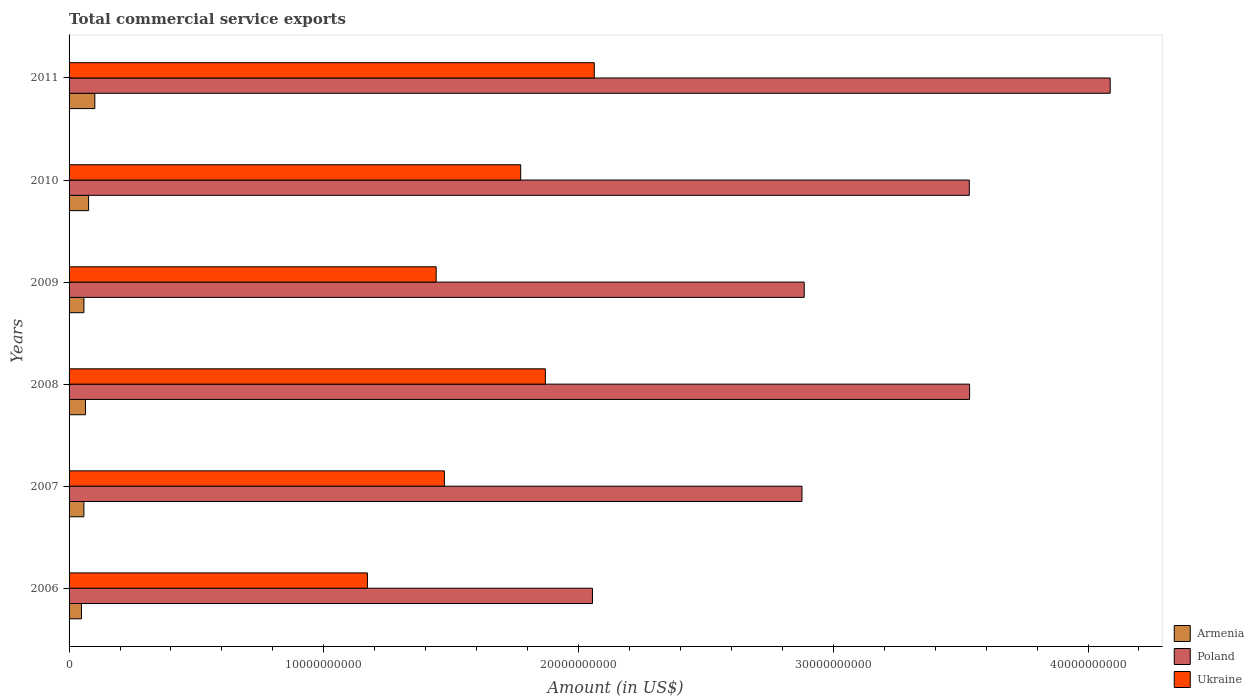How many bars are there on the 2nd tick from the top?
Give a very brief answer. 3. What is the label of the 3rd group of bars from the top?
Ensure brevity in your answer.  2009. In how many cases, is the number of bars for a given year not equal to the number of legend labels?
Provide a short and direct response. 0. What is the total commercial service exports in Ukraine in 2010?
Provide a succinct answer. 1.77e+1. Across all years, what is the maximum total commercial service exports in Poland?
Your response must be concise. 4.09e+1. Across all years, what is the minimum total commercial service exports in Poland?
Offer a terse response. 2.05e+1. In which year was the total commercial service exports in Ukraine maximum?
Offer a very short reply. 2011. What is the total total commercial service exports in Poland in the graph?
Your answer should be compact. 1.90e+11. What is the difference between the total commercial service exports in Armenia in 2008 and that in 2010?
Offer a very short reply. -1.21e+08. What is the difference between the total commercial service exports in Ukraine in 2010 and the total commercial service exports in Armenia in 2008?
Give a very brief answer. 1.71e+1. What is the average total commercial service exports in Armenia per year?
Keep it short and to the point. 6.79e+08. In the year 2009, what is the difference between the total commercial service exports in Poland and total commercial service exports in Armenia?
Your response must be concise. 2.83e+1. In how many years, is the total commercial service exports in Armenia greater than 38000000000 US$?
Make the answer very short. 0. What is the ratio of the total commercial service exports in Ukraine in 2010 to that in 2011?
Ensure brevity in your answer.  0.86. Is the total commercial service exports in Armenia in 2006 less than that in 2008?
Provide a short and direct response. Yes. Is the difference between the total commercial service exports in Poland in 2007 and 2008 greater than the difference between the total commercial service exports in Armenia in 2007 and 2008?
Provide a short and direct response. No. What is the difference between the highest and the second highest total commercial service exports in Ukraine?
Provide a succinct answer. 1.92e+09. What is the difference between the highest and the lowest total commercial service exports in Ukraine?
Your answer should be very brief. 8.90e+09. In how many years, is the total commercial service exports in Ukraine greater than the average total commercial service exports in Ukraine taken over all years?
Keep it short and to the point. 3. What does the 3rd bar from the bottom in 2011 represents?
Offer a very short reply. Ukraine. How many bars are there?
Provide a succinct answer. 18. Are all the bars in the graph horizontal?
Offer a very short reply. Yes. How many years are there in the graph?
Offer a terse response. 6. Are the values on the major ticks of X-axis written in scientific E-notation?
Your answer should be very brief. No. Does the graph contain grids?
Provide a short and direct response. No. How many legend labels are there?
Your answer should be very brief. 3. How are the legend labels stacked?
Your answer should be very brief. Vertical. What is the title of the graph?
Make the answer very short. Total commercial service exports. Does "San Marino" appear as one of the legend labels in the graph?
Provide a succinct answer. No. What is the label or title of the X-axis?
Provide a short and direct response. Amount (in US$). What is the Amount (in US$) of Armenia in 2006?
Make the answer very short. 4.87e+08. What is the Amount (in US$) in Poland in 2006?
Give a very brief answer. 2.05e+1. What is the Amount (in US$) of Ukraine in 2006?
Your response must be concise. 1.17e+1. What is the Amount (in US$) of Armenia in 2007?
Make the answer very short. 5.82e+08. What is the Amount (in US$) of Poland in 2007?
Offer a terse response. 2.88e+1. What is the Amount (in US$) of Ukraine in 2007?
Provide a short and direct response. 1.47e+1. What is the Amount (in US$) in Armenia in 2008?
Give a very brief answer. 6.45e+08. What is the Amount (in US$) in Poland in 2008?
Keep it short and to the point. 3.54e+1. What is the Amount (in US$) in Ukraine in 2008?
Offer a very short reply. 1.87e+1. What is the Amount (in US$) of Armenia in 2009?
Offer a very short reply. 5.83e+08. What is the Amount (in US$) of Poland in 2009?
Keep it short and to the point. 2.89e+1. What is the Amount (in US$) in Ukraine in 2009?
Provide a succinct answer. 1.44e+1. What is the Amount (in US$) in Armenia in 2010?
Offer a terse response. 7.66e+08. What is the Amount (in US$) in Poland in 2010?
Provide a succinct answer. 3.53e+1. What is the Amount (in US$) in Ukraine in 2010?
Your answer should be very brief. 1.77e+1. What is the Amount (in US$) in Armenia in 2011?
Your answer should be compact. 1.01e+09. What is the Amount (in US$) of Poland in 2011?
Provide a succinct answer. 4.09e+1. What is the Amount (in US$) of Ukraine in 2011?
Give a very brief answer. 2.06e+1. Across all years, what is the maximum Amount (in US$) of Armenia?
Ensure brevity in your answer.  1.01e+09. Across all years, what is the maximum Amount (in US$) in Poland?
Provide a succinct answer. 4.09e+1. Across all years, what is the maximum Amount (in US$) in Ukraine?
Provide a short and direct response. 2.06e+1. Across all years, what is the minimum Amount (in US$) of Armenia?
Offer a terse response. 4.87e+08. Across all years, what is the minimum Amount (in US$) in Poland?
Ensure brevity in your answer.  2.05e+1. Across all years, what is the minimum Amount (in US$) of Ukraine?
Give a very brief answer. 1.17e+1. What is the total Amount (in US$) of Armenia in the graph?
Your response must be concise. 4.08e+09. What is the total Amount (in US$) in Poland in the graph?
Ensure brevity in your answer.  1.90e+11. What is the total Amount (in US$) of Ukraine in the graph?
Ensure brevity in your answer.  9.79e+1. What is the difference between the Amount (in US$) in Armenia in 2006 and that in 2007?
Provide a succinct answer. -9.43e+07. What is the difference between the Amount (in US$) of Poland in 2006 and that in 2007?
Ensure brevity in your answer.  -8.22e+09. What is the difference between the Amount (in US$) in Ukraine in 2006 and that in 2007?
Give a very brief answer. -3.02e+09. What is the difference between the Amount (in US$) in Armenia in 2006 and that in 2008?
Your answer should be very brief. -1.58e+08. What is the difference between the Amount (in US$) in Poland in 2006 and that in 2008?
Your answer should be compact. -1.48e+1. What is the difference between the Amount (in US$) of Ukraine in 2006 and that in 2008?
Your answer should be very brief. -6.99e+09. What is the difference between the Amount (in US$) in Armenia in 2006 and that in 2009?
Provide a short and direct response. -9.58e+07. What is the difference between the Amount (in US$) of Poland in 2006 and that in 2009?
Your answer should be very brief. -8.31e+09. What is the difference between the Amount (in US$) in Ukraine in 2006 and that in 2009?
Keep it short and to the point. -2.70e+09. What is the difference between the Amount (in US$) of Armenia in 2006 and that in 2010?
Ensure brevity in your answer.  -2.79e+08. What is the difference between the Amount (in US$) of Poland in 2006 and that in 2010?
Your response must be concise. -1.48e+1. What is the difference between the Amount (in US$) of Ukraine in 2006 and that in 2010?
Keep it short and to the point. -6.02e+09. What is the difference between the Amount (in US$) of Armenia in 2006 and that in 2011?
Ensure brevity in your answer.  -5.24e+08. What is the difference between the Amount (in US$) in Poland in 2006 and that in 2011?
Offer a terse response. -2.03e+1. What is the difference between the Amount (in US$) in Ukraine in 2006 and that in 2011?
Provide a short and direct response. -8.90e+09. What is the difference between the Amount (in US$) in Armenia in 2007 and that in 2008?
Provide a succinct answer. -6.33e+07. What is the difference between the Amount (in US$) in Poland in 2007 and that in 2008?
Give a very brief answer. -6.58e+09. What is the difference between the Amount (in US$) of Ukraine in 2007 and that in 2008?
Make the answer very short. -3.96e+09. What is the difference between the Amount (in US$) in Armenia in 2007 and that in 2009?
Ensure brevity in your answer.  -1.47e+06. What is the difference between the Amount (in US$) of Poland in 2007 and that in 2009?
Your answer should be compact. -8.80e+07. What is the difference between the Amount (in US$) of Ukraine in 2007 and that in 2009?
Your answer should be compact. 3.23e+08. What is the difference between the Amount (in US$) of Armenia in 2007 and that in 2010?
Your answer should be very brief. -1.85e+08. What is the difference between the Amount (in US$) in Poland in 2007 and that in 2010?
Keep it short and to the point. -6.57e+09. What is the difference between the Amount (in US$) of Ukraine in 2007 and that in 2010?
Make the answer very short. -3.00e+09. What is the difference between the Amount (in US$) of Armenia in 2007 and that in 2011?
Your response must be concise. -4.30e+08. What is the difference between the Amount (in US$) in Poland in 2007 and that in 2011?
Provide a succinct answer. -1.21e+1. What is the difference between the Amount (in US$) in Ukraine in 2007 and that in 2011?
Your response must be concise. -5.88e+09. What is the difference between the Amount (in US$) of Armenia in 2008 and that in 2009?
Provide a succinct answer. 6.18e+07. What is the difference between the Amount (in US$) of Poland in 2008 and that in 2009?
Provide a succinct answer. 6.49e+09. What is the difference between the Amount (in US$) of Ukraine in 2008 and that in 2009?
Ensure brevity in your answer.  4.29e+09. What is the difference between the Amount (in US$) in Armenia in 2008 and that in 2010?
Your answer should be compact. -1.21e+08. What is the difference between the Amount (in US$) of Poland in 2008 and that in 2010?
Provide a short and direct response. 1.10e+07. What is the difference between the Amount (in US$) of Ukraine in 2008 and that in 2010?
Ensure brevity in your answer.  9.70e+08. What is the difference between the Amount (in US$) of Armenia in 2008 and that in 2011?
Provide a short and direct response. -3.66e+08. What is the difference between the Amount (in US$) of Poland in 2008 and that in 2011?
Your answer should be compact. -5.52e+09. What is the difference between the Amount (in US$) of Ukraine in 2008 and that in 2011?
Ensure brevity in your answer.  -1.92e+09. What is the difference between the Amount (in US$) in Armenia in 2009 and that in 2010?
Provide a succinct answer. -1.83e+08. What is the difference between the Amount (in US$) of Poland in 2009 and that in 2010?
Offer a terse response. -6.48e+09. What is the difference between the Amount (in US$) in Ukraine in 2009 and that in 2010?
Your response must be concise. -3.32e+09. What is the difference between the Amount (in US$) of Armenia in 2009 and that in 2011?
Your answer should be very brief. -4.28e+08. What is the difference between the Amount (in US$) of Poland in 2009 and that in 2011?
Your answer should be very brief. -1.20e+1. What is the difference between the Amount (in US$) in Ukraine in 2009 and that in 2011?
Provide a short and direct response. -6.21e+09. What is the difference between the Amount (in US$) in Armenia in 2010 and that in 2011?
Ensure brevity in your answer.  -2.45e+08. What is the difference between the Amount (in US$) of Poland in 2010 and that in 2011?
Keep it short and to the point. -5.53e+09. What is the difference between the Amount (in US$) in Ukraine in 2010 and that in 2011?
Give a very brief answer. -2.89e+09. What is the difference between the Amount (in US$) in Armenia in 2006 and the Amount (in US$) in Poland in 2007?
Offer a terse response. -2.83e+1. What is the difference between the Amount (in US$) of Armenia in 2006 and the Amount (in US$) of Ukraine in 2007?
Give a very brief answer. -1.42e+1. What is the difference between the Amount (in US$) of Poland in 2006 and the Amount (in US$) of Ukraine in 2007?
Provide a short and direct response. 5.81e+09. What is the difference between the Amount (in US$) in Armenia in 2006 and the Amount (in US$) in Poland in 2008?
Provide a succinct answer. -3.49e+1. What is the difference between the Amount (in US$) of Armenia in 2006 and the Amount (in US$) of Ukraine in 2008?
Make the answer very short. -1.82e+1. What is the difference between the Amount (in US$) in Poland in 2006 and the Amount (in US$) in Ukraine in 2008?
Provide a short and direct response. 1.85e+09. What is the difference between the Amount (in US$) of Armenia in 2006 and the Amount (in US$) of Poland in 2009?
Your response must be concise. -2.84e+1. What is the difference between the Amount (in US$) in Armenia in 2006 and the Amount (in US$) in Ukraine in 2009?
Keep it short and to the point. -1.39e+1. What is the difference between the Amount (in US$) of Poland in 2006 and the Amount (in US$) of Ukraine in 2009?
Provide a short and direct response. 6.14e+09. What is the difference between the Amount (in US$) in Armenia in 2006 and the Amount (in US$) in Poland in 2010?
Your answer should be very brief. -3.49e+1. What is the difference between the Amount (in US$) of Armenia in 2006 and the Amount (in US$) of Ukraine in 2010?
Your response must be concise. -1.72e+1. What is the difference between the Amount (in US$) of Poland in 2006 and the Amount (in US$) of Ukraine in 2010?
Give a very brief answer. 2.82e+09. What is the difference between the Amount (in US$) of Armenia in 2006 and the Amount (in US$) of Poland in 2011?
Your answer should be compact. -4.04e+1. What is the difference between the Amount (in US$) of Armenia in 2006 and the Amount (in US$) of Ukraine in 2011?
Ensure brevity in your answer.  -2.01e+1. What is the difference between the Amount (in US$) of Poland in 2006 and the Amount (in US$) of Ukraine in 2011?
Your response must be concise. -7.10e+07. What is the difference between the Amount (in US$) in Armenia in 2007 and the Amount (in US$) in Poland in 2008?
Ensure brevity in your answer.  -3.48e+1. What is the difference between the Amount (in US$) in Armenia in 2007 and the Amount (in US$) in Ukraine in 2008?
Ensure brevity in your answer.  -1.81e+1. What is the difference between the Amount (in US$) in Poland in 2007 and the Amount (in US$) in Ukraine in 2008?
Provide a succinct answer. 1.01e+1. What is the difference between the Amount (in US$) of Armenia in 2007 and the Amount (in US$) of Poland in 2009?
Provide a succinct answer. -2.83e+1. What is the difference between the Amount (in US$) of Armenia in 2007 and the Amount (in US$) of Ukraine in 2009?
Ensure brevity in your answer.  -1.38e+1. What is the difference between the Amount (in US$) of Poland in 2007 and the Amount (in US$) of Ukraine in 2009?
Your response must be concise. 1.44e+1. What is the difference between the Amount (in US$) in Armenia in 2007 and the Amount (in US$) in Poland in 2010?
Provide a succinct answer. -3.48e+1. What is the difference between the Amount (in US$) of Armenia in 2007 and the Amount (in US$) of Ukraine in 2010?
Your answer should be compact. -1.71e+1. What is the difference between the Amount (in US$) in Poland in 2007 and the Amount (in US$) in Ukraine in 2010?
Your answer should be compact. 1.10e+1. What is the difference between the Amount (in US$) of Armenia in 2007 and the Amount (in US$) of Poland in 2011?
Your response must be concise. -4.03e+1. What is the difference between the Amount (in US$) of Armenia in 2007 and the Amount (in US$) of Ukraine in 2011?
Provide a short and direct response. -2.00e+1. What is the difference between the Amount (in US$) of Poland in 2007 and the Amount (in US$) of Ukraine in 2011?
Ensure brevity in your answer.  8.15e+09. What is the difference between the Amount (in US$) of Armenia in 2008 and the Amount (in US$) of Poland in 2009?
Provide a succinct answer. -2.82e+1. What is the difference between the Amount (in US$) in Armenia in 2008 and the Amount (in US$) in Ukraine in 2009?
Keep it short and to the point. -1.38e+1. What is the difference between the Amount (in US$) in Poland in 2008 and the Amount (in US$) in Ukraine in 2009?
Make the answer very short. 2.09e+1. What is the difference between the Amount (in US$) in Armenia in 2008 and the Amount (in US$) in Poland in 2010?
Provide a succinct answer. -3.47e+1. What is the difference between the Amount (in US$) in Armenia in 2008 and the Amount (in US$) in Ukraine in 2010?
Your answer should be very brief. -1.71e+1. What is the difference between the Amount (in US$) of Poland in 2008 and the Amount (in US$) of Ukraine in 2010?
Your response must be concise. 1.76e+1. What is the difference between the Amount (in US$) in Armenia in 2008 and the Amount (in US$) in Poland in 2011?
Make the answer very short. -4.02e+1. What is the difference between the Amount (in US$) of Armenia in 2008 and the Amount (in US$) of Ukraine in 2011?
Offer a very short reply. -2.00e+1. What is the difference between the Amount (in US$) in Poland in 2008 and the Amount (in US$) in Ukraine in 2011?
Your response must be concise. 1.47e+1. What is the difference between the Amount (in US$) of Armenia in 2009 and the Amount (in US$) of Poland in 2010?
Your response must be concise. -3.48e+1. What is the difference between the Amount (in US$) of Armenia in 2009 and the Amount (in US$) of Ukraine in 2010?
Offer a terse response. -1.71e+1. What is the difference between the Amount (in US$) of Poland in 2009 and the Amount (in US$) of Ukraine in 2010?
Provide a short and direct response. 1.11e+1. What is the difference between the Amount (in US$) in Armenia in 2009 and the Amount (in US$) in Poland in 2011?
Your answer should be very brief. -4.03e+1. What is the difference between the Amount (in US$) of Armenia in 2009 and the Amount (in US$) of Ukraine in 2011?
Give a very brief answer. -2.00e+1. What is the difference between the Amount (in US$) of Poland in 2009 and the Amount (in US$) of Ukraine in 2011?
Keep it short and to the point. 8.24e+09. What is the difference between the Amount (in US$) in Armenia in 2010 and the Amount (in US$) in Poland in 2011?
Offer a very short reply. -4.01e+1. What is the difference between the Amount (in US$) of Armenia in 2010 and the Amount (in US$) of Ukraine in 2011?
Keep it short and to the point. -1.99e+1. What is the difference between the Amount (in US$) in Poland in 2010 and the Amount (in US$) in Ukraine in 2011?
Give a very brief answer. 1.47e+1. What is the average Amount (in US$) in Armenia per year?
Make the answer very short. 6.79e+08. What is the average Amount (in US$) of Poland per year?
Ensure brevity in your answer.  3.16e+1. What is the average Amount (in US$) of Ukraine per year?
Make the answer very short. 1.63e+1. In the year 2006, what is the difference between the Amount (in US$) of Armenia and Amount (in US$) of Poland?
Give a very brief answer. -2.01e+1. In the year 2006, what is the difference between the Amount (in US$) of Armenia and Amount (in US$) of Ukraine?
Your response must be concise. -1.12e+1. In the year 2006, what is the difference between the Amount (in US$) of Poland and Amount (in US$) of Ukraine?
Your answer should be very brief. 8.83e+09. In the year 2007, what is the difference between the Amount (in US$) in Armenia and Amount (in US$) in Poland?
Keep it short and to the point. -2.82e+1. In the year 2007, what is the difference between the Amount (in US$) in Armenia and Amount (in US$) in Ukraine?
Give a very brief answer. -1.42e+1. In the year 2007, what is the difference between the Amount (in US$) of Poland and Amount (in US$) of Ukraine?
Provide a short and direct response. 1.40e+1. In the year 2008, what is the difference between the Amount (in US$) of Armenia and Amount (in US$) of Poland?
Provide a short and direct response. -3.47e+1. In the year 2008, what is the difference between the Amount (in US$) in Armenia and Amount (in US$) in Ukraine?
Give a very brief answer. -1.81e+1. In the year 2008, what is the difference between the Amount (in US$) in Poland and Amount (in US$) in Ukraine?
Provide a short and direct response. 1.67e+1. In the year 2009, what is the difference between the Amount (in US$) of Armenia and Amount (in US$) of Poland?
Your response must be concise. -2.83e+1. In the year 2009, what is the difference between the Amount (in US$) of Armenia and Amount (in US$) of Ukraine?
Provide a short and direct response. -1.38e+1. In the year 2009, what is the difference between the Amount (in US$) of Poland and Amount (in US$) of Ukraine?
Offer a terse response. 1.44e+1. In the year 2010, what is the difference between the Amount (in US$) in Armenia and Amount (in US$) in Poland?
Provide a short and direct response. -3.46e+1. In the year 2010, what is the difference between the Amount (in US$) of Armenia and Amount (in US$) of Ukraine?
Ensure brevity in your answer.  -1.70e+1. In the year 2010, what is the difference between the Amount (in US$) of Poland and Amount (in US$) of Ukraine?
Ensure brevity in your answer.  1.76e+1. In the year 2011, what is the difference between the Amount (in US$) in Armenia and Amount (in US$) in Poland?
Provide a succinct answer. -3.99e+1. In the year 2011, what is the difference between the Amount (in US$) in Armenia and Amount (in US$) in Ukraine?
Give a very brief answer. -1.96e+1. In the year 2011, what is the difference between the Amount (in US$) of Poland and Amount (in US$) of Ukraine?
Keep it short and to the point. 2.03e+1. What is the ratio of the Amount (in US$) in Armenia in 2006 to that in 2007?
Keep it short and to the point. 0.84. What is the ratio of the Amount (in US$) in Poland in 2006 to that in 2007?
Your response must be concise. 0.71. What is the ratio of the Amount (in US$) of Ukraine in 2006 to that in 2007?
Your answer should be compact. 0.8. What is the ratio of the Amount (in US$) of Armenia in 2006 to that in 2008?
Provide a short and direct response. 0.76. What is the ratio of the Amount (in US$) in Poland in 2006 to that in 2008?
Provide a succinct answer. 0.58. What is the ratio of the Amount (in US$) of Ukraine in 2006 to that in 2008?
Your answer should be compact. 0.63. What is the ratio of the Amount (in US$) of Armenia in 2006 to that in 2009?
Offer a terse response. 0.84. What is the ratio of the Amount (in US$) of Poland in 2006 to that in 2009?
Provide a succinct answer. 0.71. What is the ratio of the Amount (in US$) in Ukraine in 2006 to that in 2009?
Your answer should be compact. 0.81. What is the ratio of the Amount (in US$) in Armenia in 2006 to that in 2010?
Your answer should be very brief. 0.64. What is the ratio of the Amount (in US$) of Poland in 2006 to that in 2010?
Offer a terse response. 0.58. What is the ratio of the Amount (in US$) of Ukraine in 2006 to that in 2010?
Your answer should be very brief. 0.66. What is the ratio of the Amount (in US$) in Armenia in 2006 to that in 2011?
Offer a very short reply. 0.48. What is the ratio of the Amount (in US$) of Poland in 2006 to that in 2011?
Keep it short and to the point. 0.5. What is the ratio of the Amount (in US$) of Ukraine in 2006 to that in 2011?
Offer a terse response. 0.57. What is the ratio of the Amount (in US$) of Armenia in 2007 to that in 2008?
Your answer should be compact. 0.9. What is the ratio of the Amount (in US$) in Poland in 2007 to that in 2008?
Make the answer very short. 0.81. What is the ratio of the Amount (in US$) of Ukraine in 2007 to that in 2008?
Provide a short and direct response. 0.79. What is the ratio of the Amount (in US$) of Ukraine in 2007 to that in 2009?
Your answer should be very brief. 1.02. What is the ratio of the Amount (in US$) of Armenia in 2007 to that in 2010?
Your answer should be compact. 0.76. What is the ratio of the Amount (in US$) of Poland in 2007 to that in 2010?
Offer a very short reply. 0.81. What is the ratio of the Amount (in US$) of Ukraine in 2007 to that in 2010?
Make the answer very short. 0.83. What is the ratio of the Amount (in US$) in Armenia in 2007 to that in 2011?
Provide a short and direct response. 0.58. What is the ratio of the Amount (in US$) of Poland in 2007 to that in 2011?
Make the answer very short. 0.7. What is the ratio of the Amount (in US$) in Ukraine in 2007 to that in 2011?
Provide a short and direct response. 0.71. What is the ratio of the Amount (in US$) in Armenia in 2008 to that in 2009?
Your answer should be very brief. 1.11. What is the ratio of the Amount (in US$) of Poland in 2008 to that in 2009?
Provide a succinct answer. 1.22. What is the ratio of the Amount (in US$) of Ukraine in 2008 to that in 2009?
Offer a very short reply. 1.3. What is the ratio of the Amount (in US$) of Armenia in 2008 to that in 2010?
Provide a short and direct response. 0.84. What is the ratio of the Amount (in US$) in Poland in 2008 to that in 2010?
Your answer should be compact. 1. What is the ratio of the Amount (in US$) in Ukraine in 2008 to that in 2010?
Your answer should be very brief. 1.05. What is the ratio of the Amount (in US$) in Armenia in 2008 to that in 2011?
Keep it short and to the point. 0.64. What is the ratio of the Amount (in US$) in Poland in 2008 to that in 2011?
Give a very brief answer. 0.86. What is the ratio of the Amount (in US$) of Ukraine in 2008 to that in 2011?
Give a very brief answer. 0.91. What is the ratio of the Amount (in US$) of Armenia in 2009 to that in 2010?
Ensure brevity in your answer.  0.76. What is the ratio of the Amount (in US$) of Poland in 2009 to that in 2010?
Offer a terse response. 0.82. What is the ratio of the Amount (in US$) in Ukraine in 2009 to that in 2010?
Offer a very short reply. 0.81. What is the ratio of the Amount (in US$) of Armenia in 2009 to that in 2011?
Keep it short and to the point. 0.58. What is the ratio of the Amount (in US$) in Poland in 2009 to that in 2011?
Provide a succinct answer. 0.71. What is the ratio of the Amount (in US$) of Ukraine in 2009 to that in 2011?
Your answer should be compact. 0.7. What is the ratio of the Amount (in US$) in Armenia in 2010 to that in 2011?
Make the answer very short. 0.76. What is the ratio of the Amount (in US$) of Poland in 2010 to that in 2011?
Your answer should be compact. 0.86. What is the ratio of the Amount (in US$) of Ukraine in 2010 to that in 2011?
Make the answer very short. 0.86. What is the difference between the highest and the second highest Amount (in US$) of Armenia?
Offer a terse response. 2.45e+08. What is the difference between the highest and the second highest Amount (in US$) of Poland?
Make the answer very short. 5.52e+09. What is the difference between the highest and the second highest Amount (in US$) in Ukraine?
Keep it short and to the point. 1.92e+09. What is the difference between the highest and the lowest Amount (in US$) of Armenia?
Keep it short and to the point. 5.24e+08. What is the difference between the highest and the lowest Amount (in US$) of Poland?
Ensure brevity in your answer.  2.03e+1. What is the difference between the highest and the lowest Amount (in US$) of Ukraine?
Your response must be concise. 8.90e+09. 